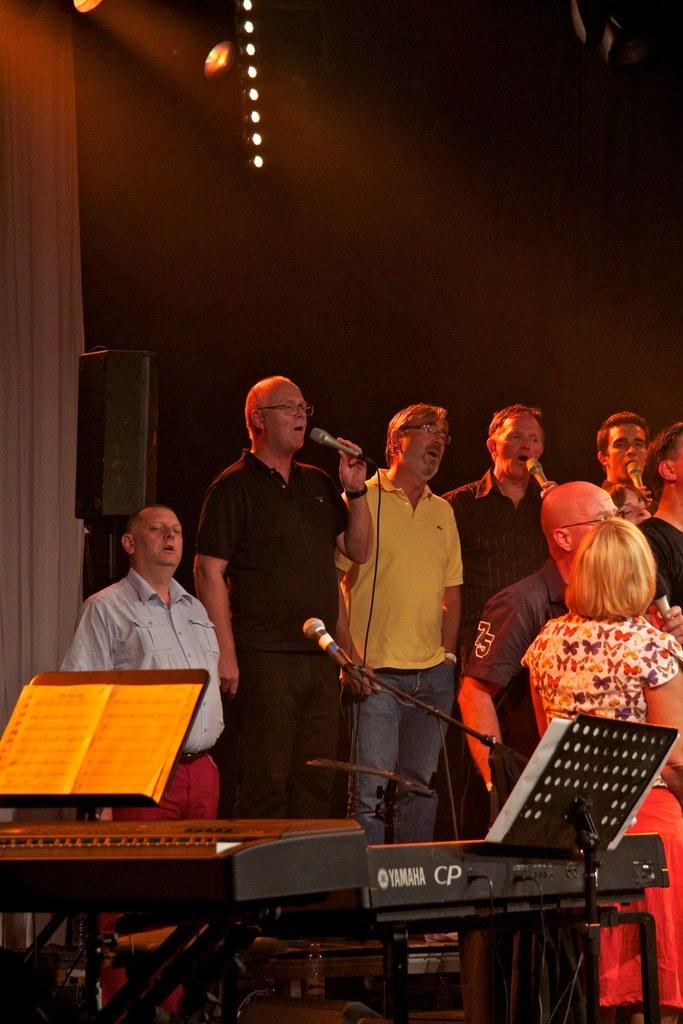<image>
Share a concise interpretation of the image provided. Adults sing on a stage near a Yamaha CP keyboard. 